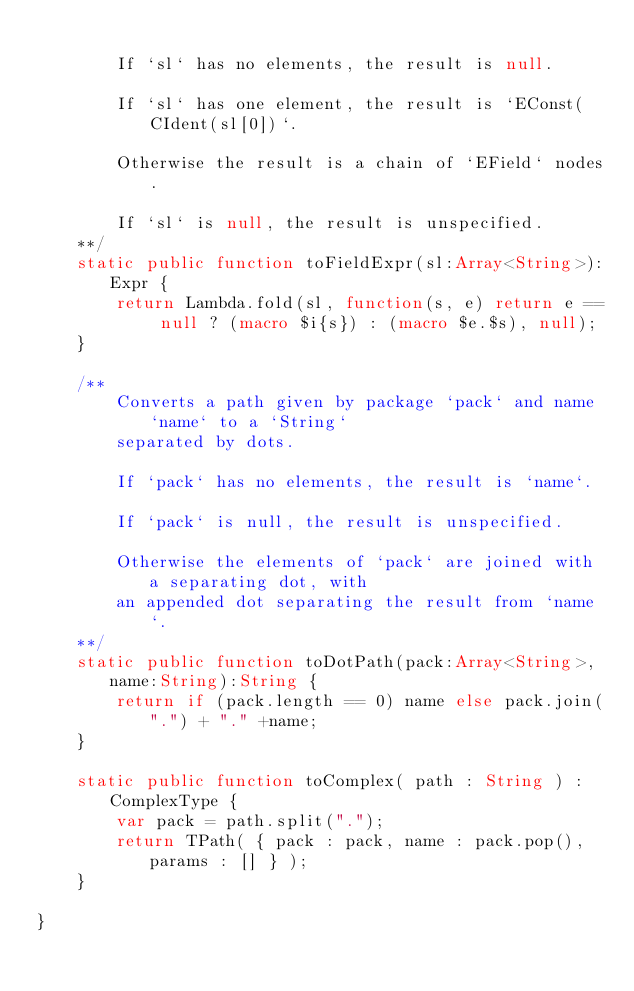Convert code to text. <code><loc_0><loc_0><loc_500><loc_500><_Haxe_>
		If `sl` has no elements, the result is null.

		If `sl` has one element, the result is `EConst(CIdent(sl[0])`.

		Otherwise the result is a chain of `EField` nodes.

		If `sl` is null, the result is unspecified.
	**/
	static public function toFieldExpr(sl:Array<String>):Expr {
		return Lambda.fold(sl, function(s, e) return e == null ? (macro $i{s}) : (macro $e.$s), null);
	}

	/**
		Converts a path given by package `pack` and name `name` to a `String`
		separated by dots.

		If `pack` has no elements, the result is `name`.

		If `pack` is null, the result is unspecified.

		Otherwise the elements of `pack` are joined with a separating dot, with
		an appended dot separating the result from `name`.
	**/
	static public function toDotPath(pack:Array<String>, name:String):String {
		return if (pack.length == 0) name else pack.join(".") + "." +name;
	}

	static public function toComplex( path : String ) : ComplexType {
		var pack = path.split(".");
		return TPath( { pack : pack, name : pack.pop(), params : [] } );
	}

}
</code> 